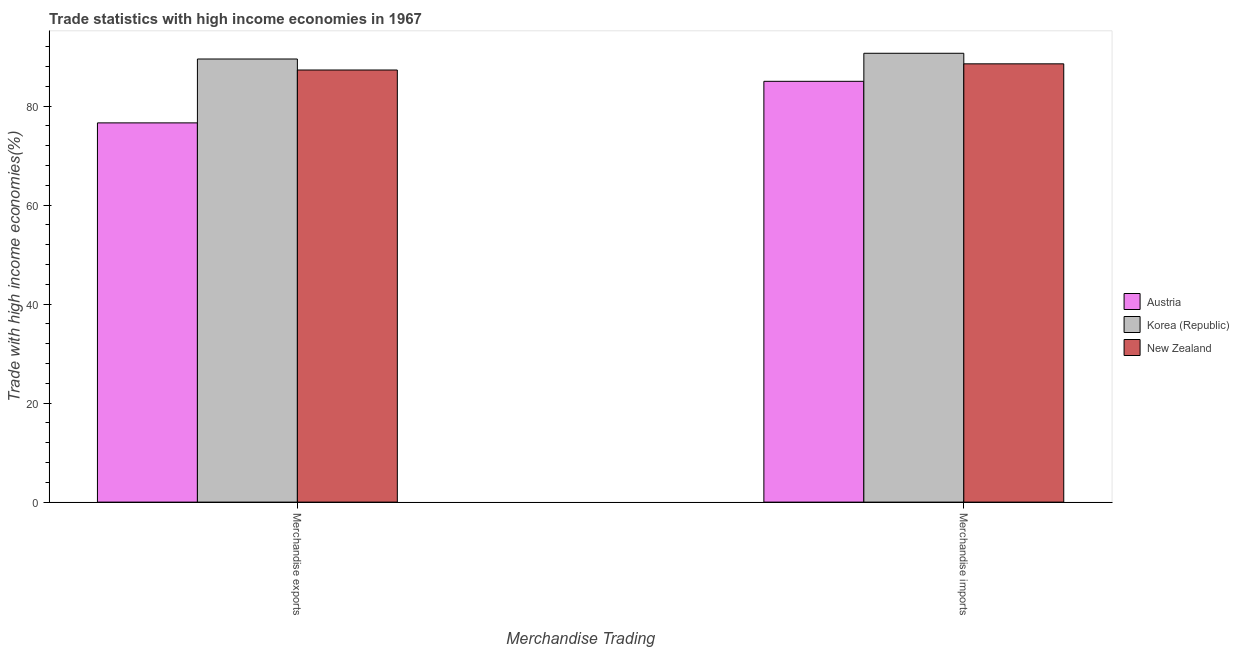How many different coloured bars are there?
Give a very brief answer. 3. How many groups of bars are there?
Provide a succinct answer. 2. Are the number of bars per tick equal to the number of legend labels?
Provide a succinct answer. Yes. Are the number of bars on each tick of the X-axis equal?
Offer a terse response. Yes. How many bars are there on the 1st tick from the left?
Offer a terse response. 3. How many bars are there on the 2nd tick from the right?
Your response must be concise. 3. What is the merchandise imports in Austria?
Ensure brevity in your answer.  85. Across all countries, what is the maximum merchandise exports?
Your response must be concise. 89.51. Across all countries, what is the minimum merchandise imports?
Offer a terse response. 85. In which country was the merchandise imports maximum?
Ensure brevity in your answer.  Korea (Republic). What is the total merchandise imports in the graph?
Keep it short and to the point. 264.21. What is the difference between the merchandise exports in Korea (Republic) and that in Austria?
Provide a short and direct response. 12.9. What is the difference between the merchandise exports in Korea (Republic) and the merchandise imports in New Zealand?
Keep it short and to the point. 0.97. What is the average merchandise exports per country?
Offer a terse response. 84.47. What is the difference between the merchandise imports and merchandise exports in Austria?
Your answer should be very brief. 8.39. In how many countries, is the merchandise exports greater than 4 %?
Ensure brevity in your answer.  3. What is the ratio of the merchandise exports in Korea (Republic) to that in Austria?
Offer a very short reply. 1.17. Is the merchandise imports in Korea (Republic) less than that in New Zealand?
Provide a short and direct response. No. In how many countries, is the merchandise exports greater than the average merchandise exports taken over all countries?
Give a very brief answer. 2. What does the 2nd bar from the right in Merchandise exports represents?
Your answer should be very brief. Korea (Republic). What is the difference between two consecutive major ticks on the Y-axis?
Keep it short and to the point. 20. Are the values on the major ticks of Y-axis written in scientific E-notation?
Provide a short and direct response. No. Does the graph contain any zero values?
Provide a short and direct response. No. Does the graph contain grids?
Make the answer very short. No. Where does the legend appear in the graph?
Make the answer very short. Center right. How many legend labels are there?
Keep it short and to the point. 3. What is the title of the graph?
Your answer should be compact. Trade statistics with high income economies in 1967. What is the label or title of the X-axis?
Keep it short and to the point. Merchandise Trading. What is the label or title of the Y-axis?
Offer a very short reply. Trade with high income economies(%). What is the Trade with high income economies(%) of Austria in Merchandise exports?
Provide a succinct answer. 76.61. What is the Trade with high income economies(%) in Korea (Republic) in Merchandise exports?
Provide a succinct answer. 89.51. What is the Trade with high income economies(%) in New Zealand in Merchandise exports?
Offer a very short reply. 87.29. What is the Trade with high income economies(%) in Austria in Merchandise imports?
Your answer should be compact. 85. What is the Trade with high income economies(%) of Korea (Republic) in Merchandise imports?
Your response must be concise. 90.67. What is the Trade with high income economies(%) in New Zealand in Merchandise imports?
Provide a short and direct response. 88.54. Across all Merchandise Trading, what is the maximum Trade with high income economies(%) of Austria?
Your response must be concise. 85. Across all Merchandise Trading, what is the maximum Trade with high income economies(%) in Korea (Republic)?
Your response must be concise. 90.67. Across all Merchandise Trading, what is the maximum Trade with high income economies(%) of New Zealand?
Your answer should be very brief. 88.54. Across all Merchandise Trading, what is the minimum Trade with high income economies(%) in Austria?
Provide a short and direct response. 76.61. Across all Merchandise Trading, what is the minimum Trade with high income economies(%) in Korea (Republic)?
Your answer should be very brief. 89.51. Across all Merchandise Trading, what is the minimum Trade with high income economies(%) in New Zealand?
Offer a very short reply. 87.29. What is the total Trade with high income economies(%) of Austria in the graph?
Provide a short and direct response. 161.62. What is the total Trade with high income economies(%) in Korea (Republic) in the graph?
Your response must be concise. 180.18. What is the total Trade with high income economies(%) of New Zealand in the graph?
Your answer should be compact. 175.83. What is the difference between the Trade with high income economies(%) in Austria in Merchandise exports and that in Merchandise imports?
Your answer should be compact. -8.39. What is the difference between the Trade with high income economies(%) in Korea (Republic) in Merchandise exports and that in Merchandise imports?
Ensure brevity in your answer.  -1.16. What is the difference between the Trade with high income economies(%) of New Zealand in Merchandise exports and that in Merchandise imports?
Provide a succinct answer. -1.25. What is the difference between the Trade with high income economies(%) in Austria in Merchandise exports and the Trade with high income economies(%) in Korea (Republic) in Merchandise imports?
Provide a succinct answer. -14.06. What is the difference between the Trade with high income economies(%) in Austria in Merchandise exports and the Trade with high income economies(%) in New Zealand in Merchandise imports?
Offer a terse response. -11.93. What is the difference between the Trade with high income economies(%) in Korea (Republic) in Merchandise exports and the Trade with high income economies(%) in New Zealand in Merchandise imports?
Keep it short and to the point. 0.97. What is the average Trade with high income economies(%) in Austria per Merchandise Trading?
Give a very brief answer. 80.81. What is the average Trade with high income economies(%) of Korea (Republic) per Merchandise Trading?
Make the answer very short. 90.09. What is the average Trade with high income economies(%) in New Zealand per Merchandise Trading?
Ensure brevity in your answer.  87.91. What is the difference between the Trade with high income economies(%) of Austria and Trade with high income economies(%) of Korea (Republic) in Merchandise exports?
Give a very brief answer. -12.9. What is the difference between the Trade with high income economies(%) of Austria and Trade with high income economies(%) of New Zealand in Merchandise exports?
Keep it short and to the point. -10.68. What is the difference between the Trade with high income economies(%) in Korea (Republic) and Trade with high income economies(%) in New Zealand in Merchandise exports?
Keep it short and to the point. 2.22. What is the difference between the Trade with high income economies(%) in Austria and Trade with high income economies(%) in Korea (Republic) in Merchandise imports?
Make the answer very short. -5.67. What is the difference between the Trade with high income economies(%) in Austria and Trade with high income economies(%) in New Zealand in Merchandise imports?
Give a very brief answer. -3.53. What is the difference between the Trade with high income economies(%) in Korea (Republic) and Trade with high income economies(%) in New Zealand in Merchandise imports?
Ensure brevity in your answer.  2.13. What is the ratio of the Trade with high income economies(%) of Austria in Merchandise exports to that in Merchandise imports?
Make the answer very short. 0.9. What is the ratio of the Trade with high income economies(%) of Korea (Republic) in Merchandise exports to that in Merchandise imports?
Give a very brief answer. 0.99. What is the ratio of the Trade with high income economies(%) of New Zealand in Merchandise exports to that in Merchandise imports?
Provide a succinct answer. 0.99. What is the difference between the highest and the second highest Trade with high income economies(%) of Austria?
Provide a succinct answer. 8.39. What is the difference between the highest and the second highest Trade with high income economies(%) in Korea (Republic)?
Offer a very short reply. 1.16. What is the difference between the highest and the second highest Trade with high income economies(%) in New Zealand?
Your answer should be very brief. 1.25. What is the difference between the highest and the lowest Trade with high income economies(%) of Austria?
Your response must be concise. 8.39. What is the difference between the highest and the lowest Trade with high income economies(%) of Korea (Republic)?
Keep it short and to the point. 1.16. What is the difference between the highest and the lowest Trade with high income economies(%) in New Zealand?
Your answer should be compact. 1.25. 